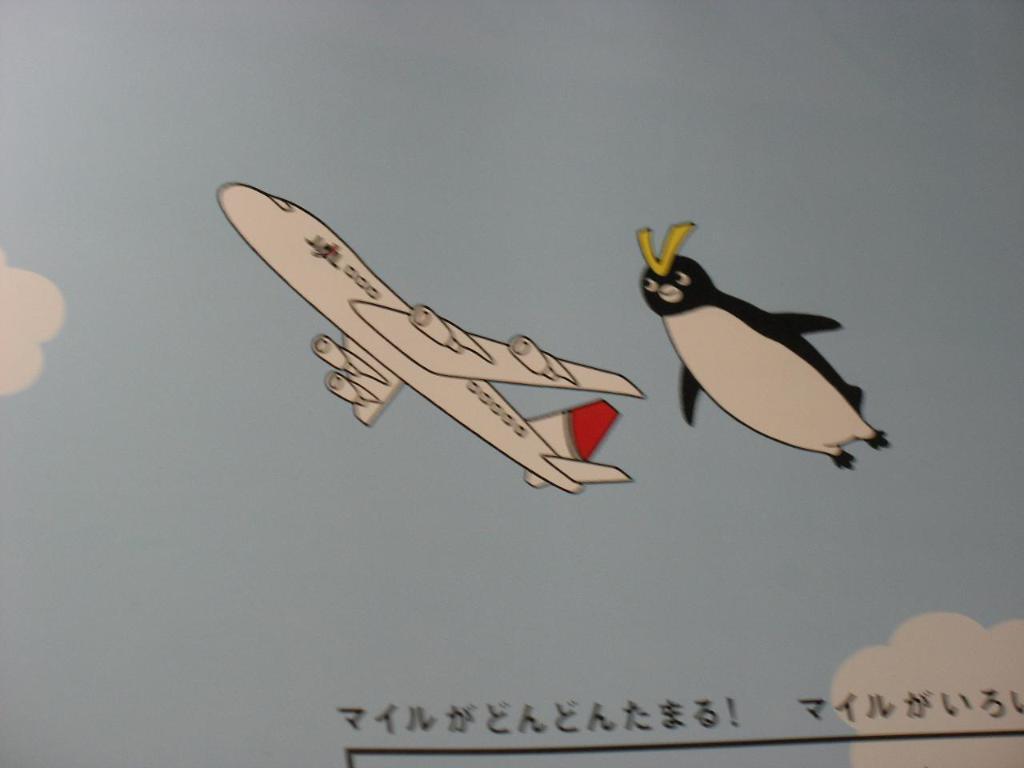How would you summarize this image in a sentence or two? In the image in the center, we can see one poster. On the poster, we can see the sky, clouds, one airplane and a penguin. And we can see something written on the paper. 